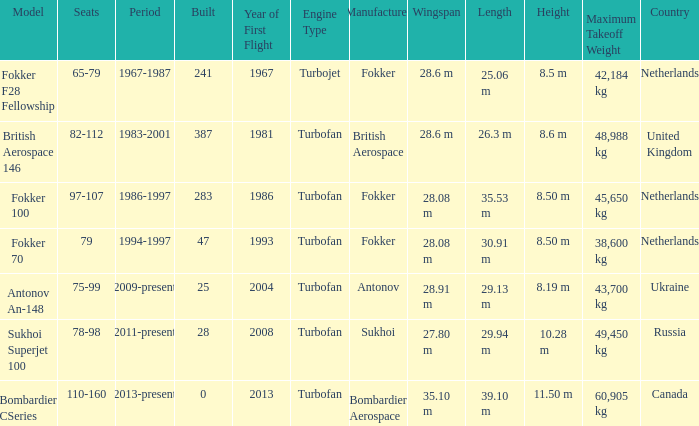Between which years were there 241 fokker 70 model cabins built? 1994-1997. 